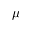Convert formula to latex. <formula><loc_0><loc_0><loc_500><loc_500>\mu</formula> 